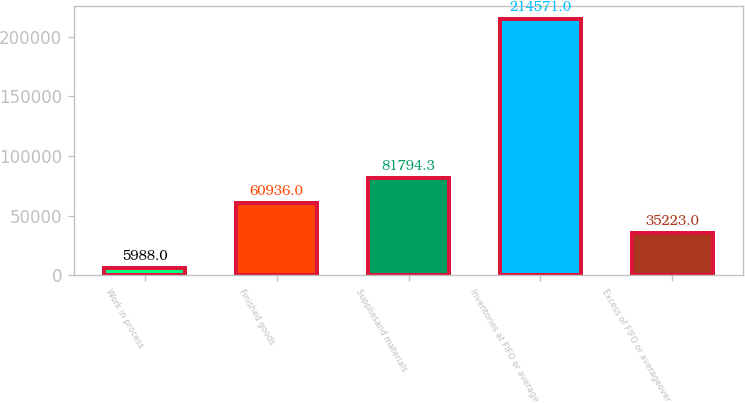Convert chart. <chart><loc_0><loc_0><loc_500><loc_500><bar_chart><fcel>Work in process<fcel>Finished goods<fcel>Suppliesand materials<fcel>Inventories at FIFO or average<fcel>Excess of FIFO or averageover<nl><fcel>5988<fcel>60936<fcel>81794.3<fcel>214571<fcel>35223<nl></chart> 